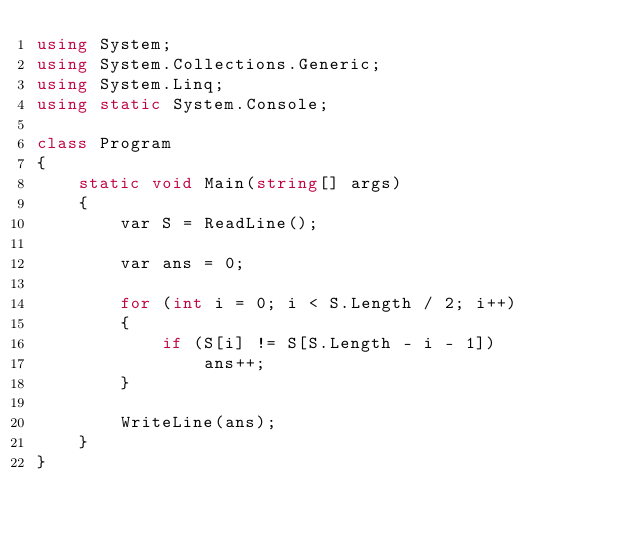<code> <loc_0><loc_0><loc_500><loc_500><_C#_>using System;
using System.Collections.Generic;
using System.Linq;
using static System.Console;

class Program
{
    static void Main(string[] args)
    {
        var S = ReadLine();

        var ans = 0;

        for (int i = 0; i < S.Length / 2; i++)
        {
            if (S[i] != S[S.Length - i - 1])
                ans++;
        }

        WriteLine(ans);
    }
}
</code> 